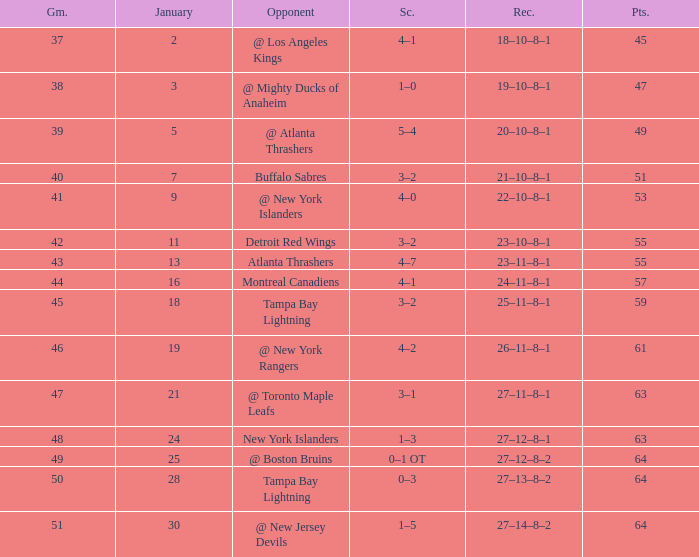Which Score has Points of 64, and a Game of 49? 0–1 OT. 